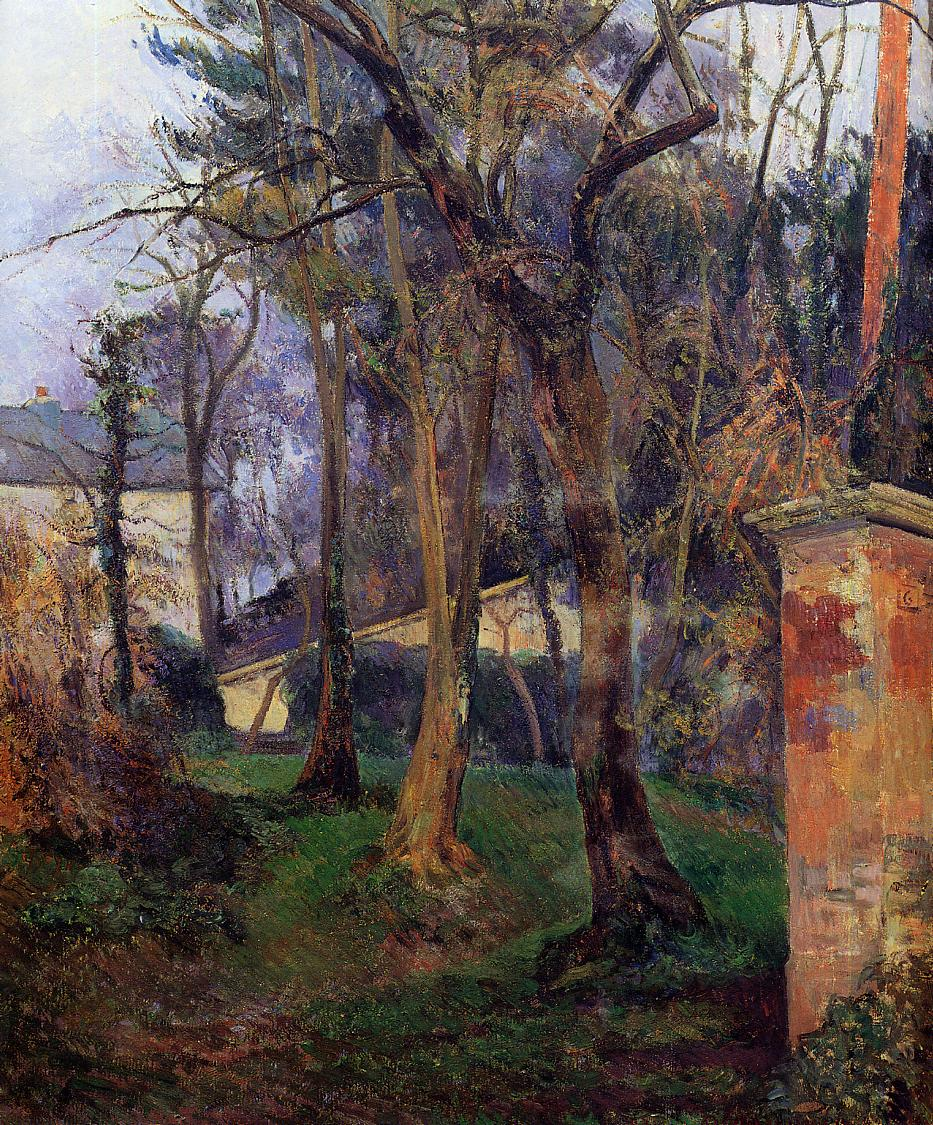If this painting could communicate, what secrets do you think it would share about its creation? If this painting could communicate, it might share secrets of early morning sessions where the artist captured the play of light as the sun rose, its rays filtering through the leaves and casting dynamic shadows. It could speak of moments of frustration and inspiration, of the artist's deep connection to nature and the emotional highs and lows experienced while bringing this scene to life. Perhaps it would reveal the artist's fondness for this particular garden, a place that held personal memories and significance, driving the desire to immortalize its beauty on canvas. 